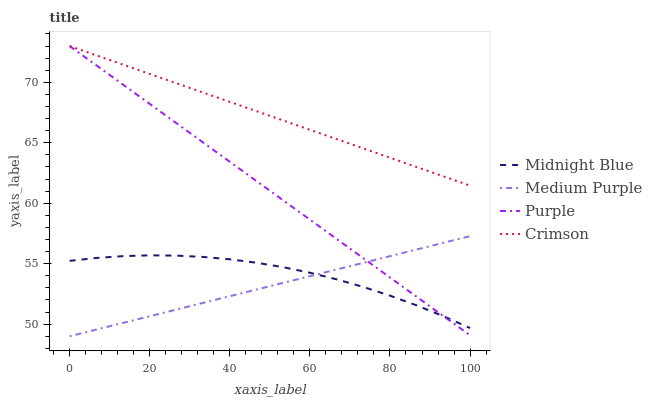Does Medium Purple have the minimum area under the curve?
Answer yes or no. Yes. Does Crimson have the maximum area under the curve?
Answer yes or no. Yes. Does Purple have the minimum area under the curve?
Answer yes or no. No. Does Purple have the maximum area under the curve?
Answer yes or no. No. Is Medium Purple the smoothest?
Answer yes or no. Yes. Is Midnight Blue the roughest?
Answer yes or no. Yes. Is Purple the smoothest?
Answer yes or no. No. Is Purple the roughest?
Answer yes or no. No. Does Medium Purple have the lowest value?
Answer yes or no. Yes. Does Purple have the lowest value?
Answer yes or no. No. Does Crimson have the highest value?
Answer yes or no. Yes. Does Midnight Blue have the highest value?
Answer yes or no. No. Is Midnight Blue less than Crimson?
Answer yes or no. Yes. Is Crimson greater than Medium Purple?
Answer yes or no. Yes. Does Medium Purple intersect Midnight Blue?
Answer yes or no. Yes. Is Medium Purple less than Midnight Blue?
Answer yes or no. No. Is Medium Purple greater than Midnight Blue?
Answer yes or no. No. Does Midnight Blue intersect Crimson?
Answer yes or no. No. 